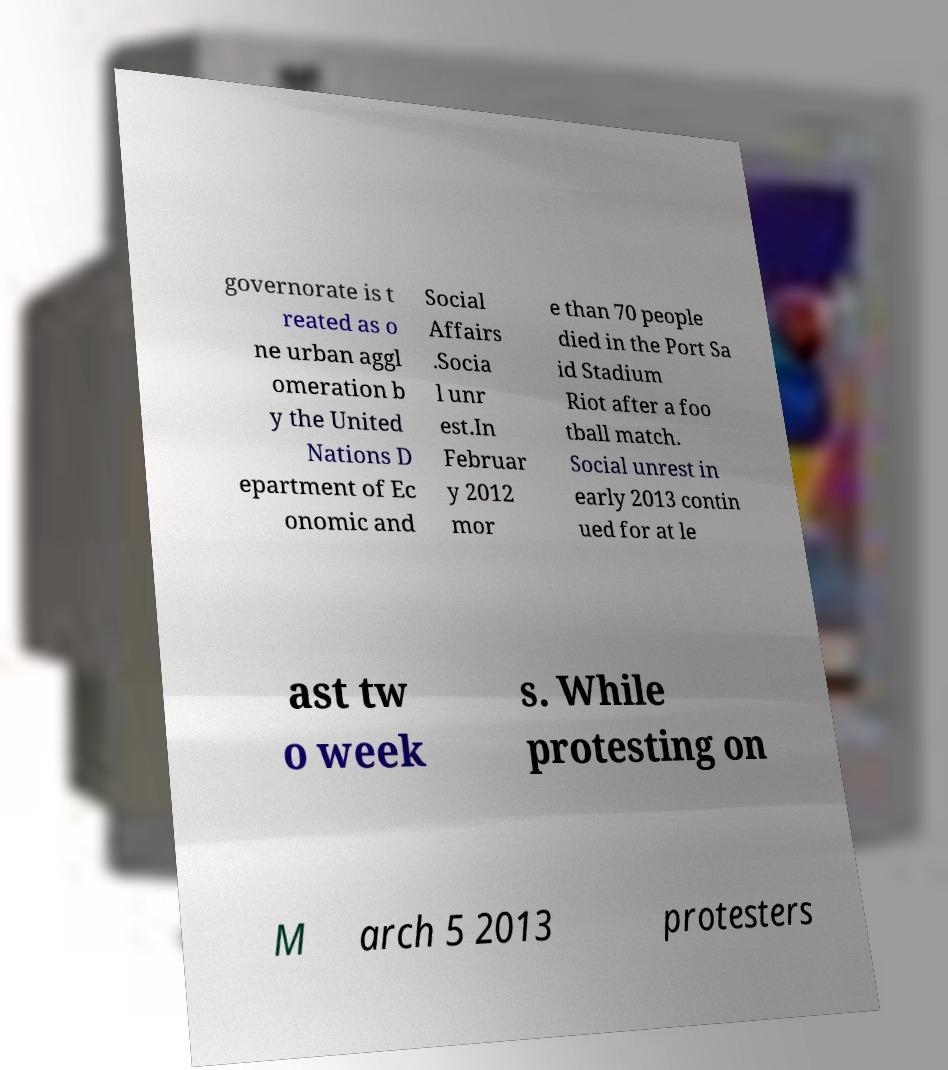Can you read and provide the text displayed in the image?This photo seems to have some interesting text. Can you extract and type it out for me? governorate is t reated as o ne urban aggl omeration b y the United Nations D epartment of Ec onomic and Social Affairs .Socia l unr est.In Februar y 2012 mor e than 70 people died in the Port Sa id Stadium Riot after a foo tball match. Social unrest in early 2013 contin ued for at le ast tw o week s. While protesting on M arch 5 2013 protesters 